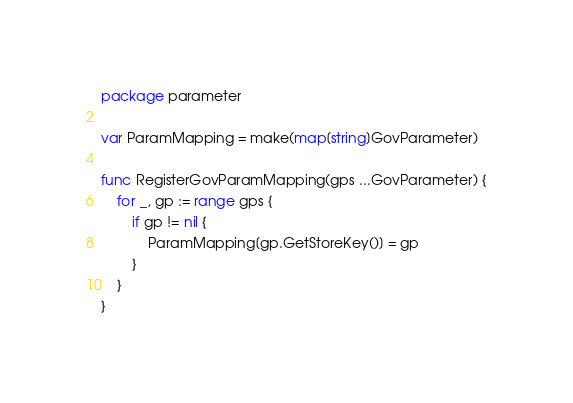Convert code to text. <code><loc_0><loc_0><loc_500><loc_500><_Go_>package parameter

var ParamMapping = make(map[string]GovParameter)

func RegisterGovParamMapping(gps ...GovParameter) {
	for _, gp := range gps {
		if gp != nil {
			ParamMapping[gp.GetStoreKey()] = gp
		}
	}
}
</code> 